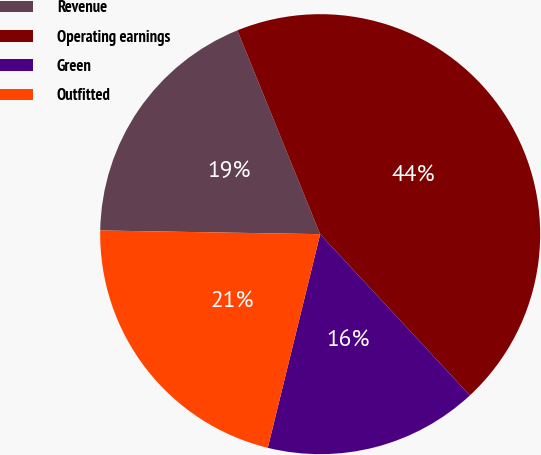<chart> <loc_0><loc_0><loc_500><loc_500><pie_chart><fcel>Revenue<fcel>Operating earnings<fcel>Green<fcel>Outfitted<nl><fcel>18.59%<fcel>44.23%<fcel>15.74%<fcel>21.44%<nl></chart> 